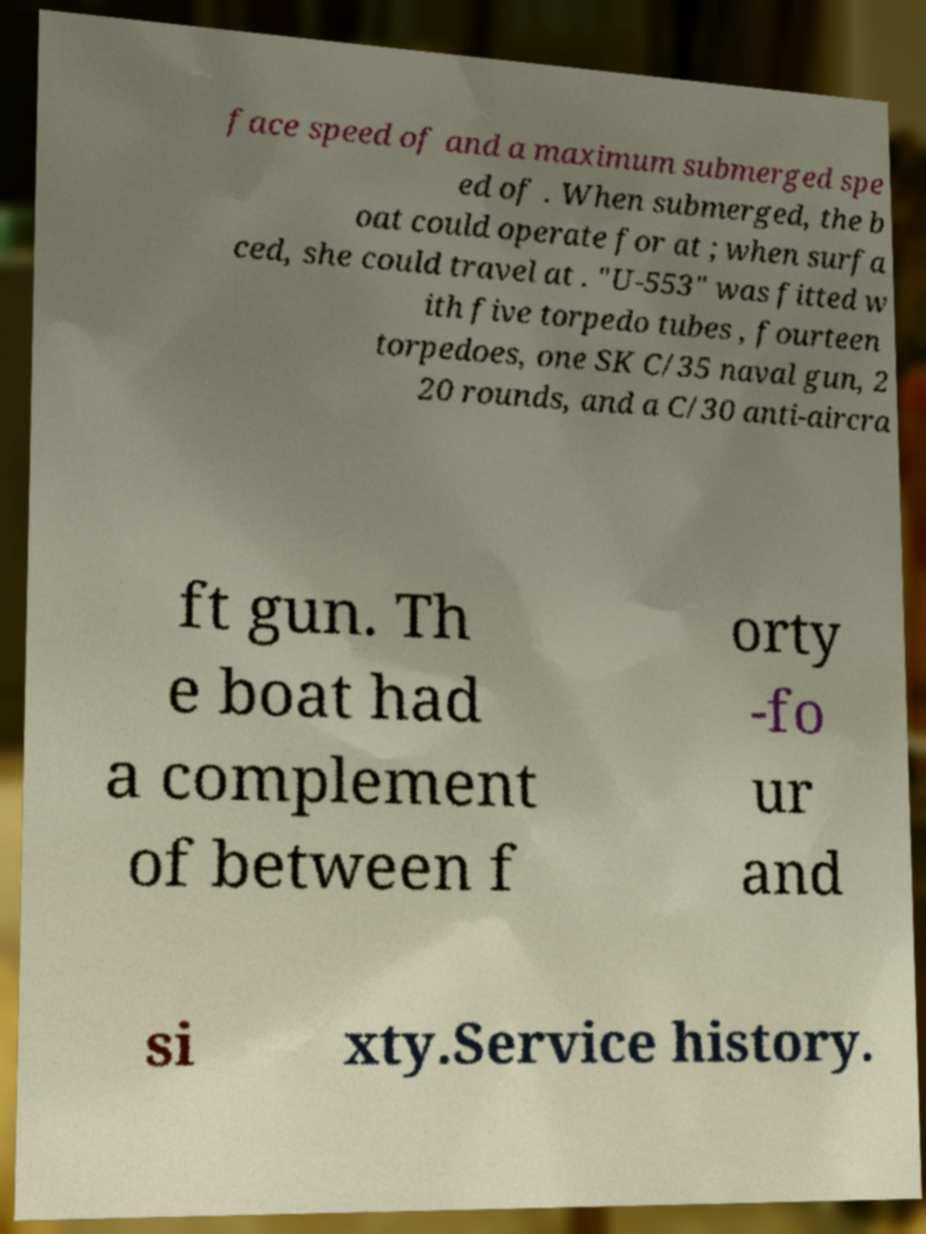Could you extract and type out the text from this image? face speed of and a maximum submerged spe ed of . When submerged, the b oat could operate for at ; when surfa ced, she could travel at . "U-553" was fitted w ith five torpedo tubes , fourteen torpedoes, one SK C/35 naval gun, 2 20 rounds, and a C/30 anti-aircra ft gun. Th e boat had a complement of between f orty -fo ur and si xty.Service history. 